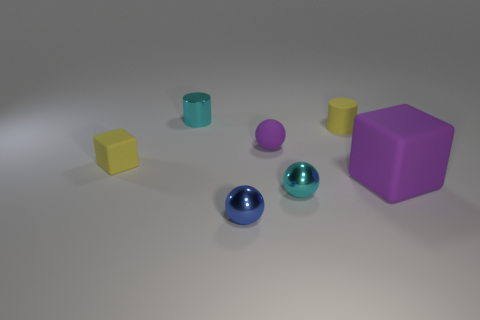Does the tiny cyan metal object in front of the big cube have the same shape as the small purple object?
Offer a terse response. Yes. What color is the small matte object that is the same shape as the large purple rubber thing?
Ensure brevity in your answer.  Yellow. The cyan metallic cylinder is what size?
Give a very brief answer. Small. Is the number of green rubber blocks less than the number of tiny blue spheres?
Provide a succinct answer. Yes. Is the shape of the blue shiny thing the same as the tiny purple rubber object?
Make the answer very short. Yes. What is the color of the matte cylinder?
Your answer should be compact. Yellow. What number of other objects are the same material as the large purple cube?
Offer a terse response. 3. How many purple things are large blocks or tiny balls?
Your answer should be very brief. 2. Does the cyan metal object behind the big purple block have the same shape as the tiny yellow rubber thing that is in front of the purple rubber ball?
Offer a very short reply. No. Do the small block and the cylinder on the right side of the tiny blue object have the same color?
Provide a short and direct response. Yes. 